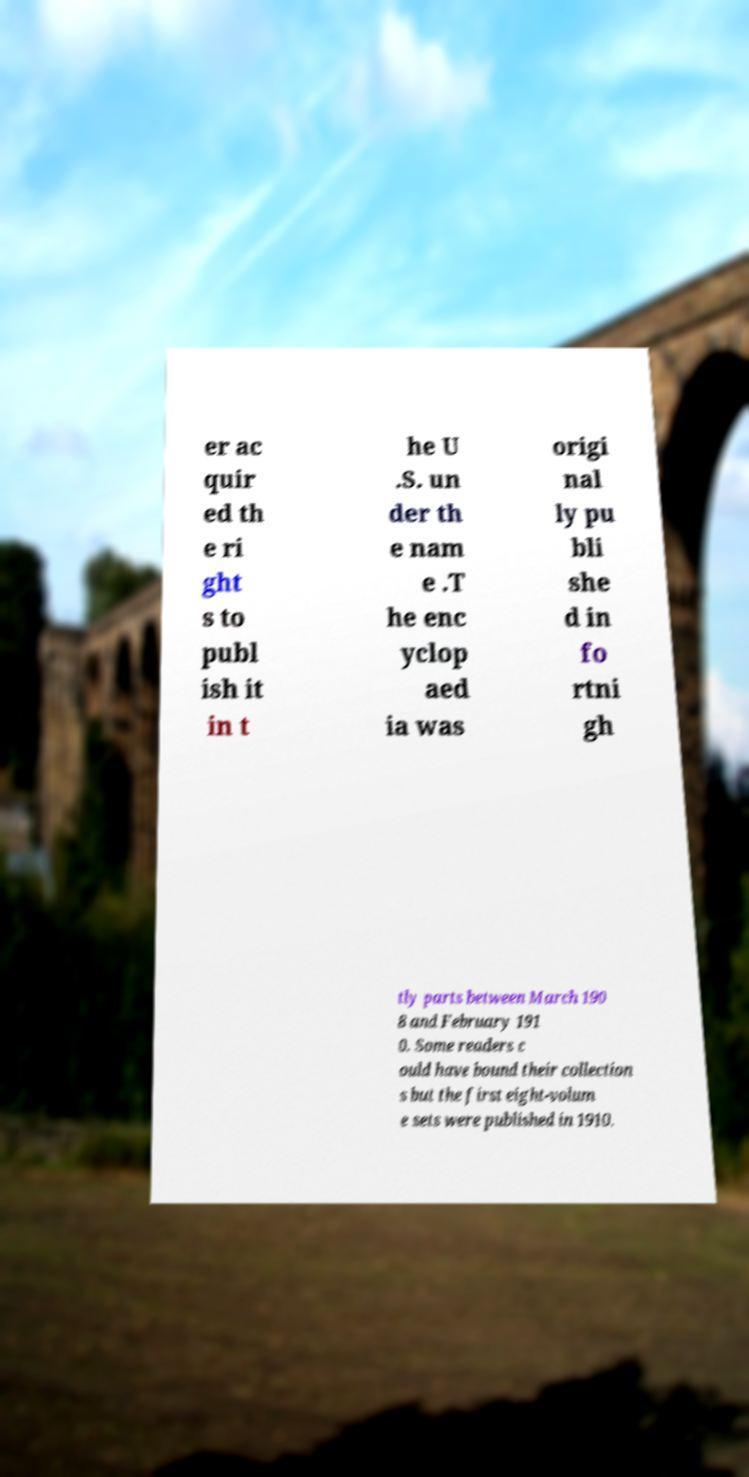Can you accurately transcribe the text from the provided image for me? er ac quir ed th e ri ght s to publ ish it in t he U .S. un der th e nam e .T he enc yclop aed ia was origi nal ly pu bli she d in fo rtni gh tly parts between March 190 8 and February 191 0. Some readers c ould have bound their collection s but the first eight-volum e sets were published in 1910. 